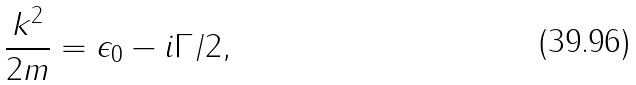Convert formula to latex. <formula><loc_0><loc_0><loc_500><loc_500>\frac { k ^ { 2 } } { 2 m } = \epsilon _ { 0 } - i \Gamma / 2 ,</formula> 